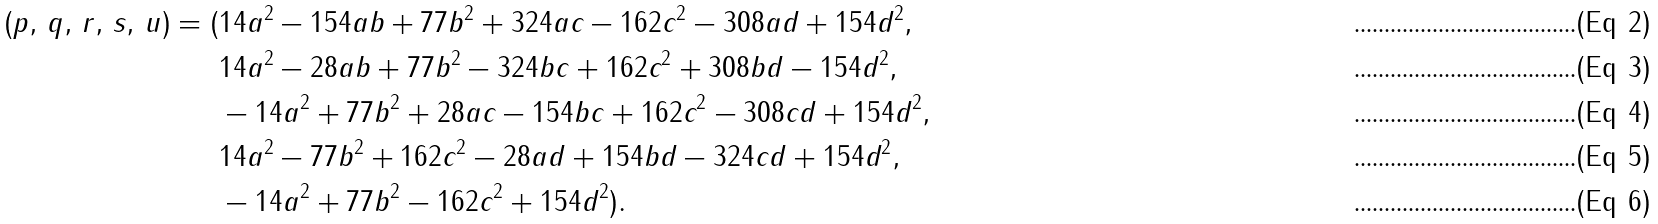<formula> <loc_0><loc_0><loc_500><loc_500>( p , \, q , \, r , \, s , \, u ) = ( & 1 4 a ^ { 2 } - 1 5 4 a b + 7 7 b ^ { 2 } + 3 2 4 a c - 1 6 2 c ^ { 2 } - 3 0 8 a d + 1 5 4 d ^ { 2 } , \\ & 1 4 a ^ { 2 } - 2 8 a b + 7 7 b ^ { 2 } - 3 2 4 b c + 1 6 2 c ^ { 2 } + 3 0 8 b d - 1 5 4 d ^ { 2 } , \\ & - 1 4 a ^ { 2 } + 7 7 b ^ { 2 } + 2 8 a c - 1 5 4 b c + 1 6 2 c ^ { 2 } - 3 0 8 c d + 1 5 4 d ^ { 2 } , \\ & 1 4 a ^ { 2 } - 7 7 b ^ { 2 } + 1 6 2 c ^ { 2 } - 2 8 a d + 1 5 4 b d - 3 2 4 c d + 1 5 4 d ^ { 2 } , \\ & - 1 4 a ^ { 2 } + 7 7 b ^ { 2 } - 1 6 2 c ^ { 2 } + 1 5 4 d ^ { 2 } ) .</formula> 